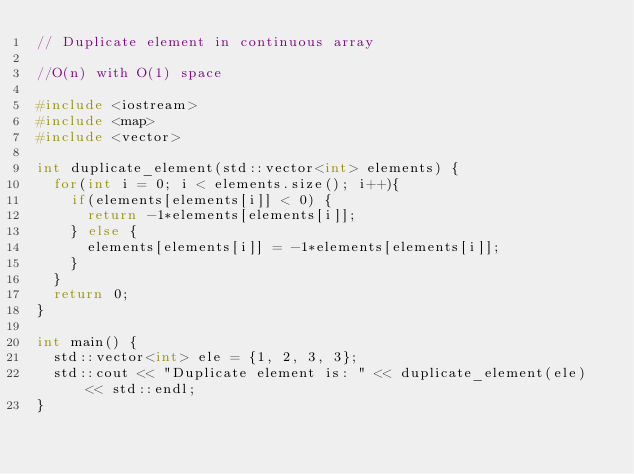<code> <loc_0><loc_0><loc_500><loc_500><_C++_>// Duplicate element in continuous array

//O(n) with O(1) space

#include <iostream>
#include <map>
#include <vector>

int duplicate_element(std::vector<int> elements) {
	for(int i = 0; i < elements.size(); i++){
		if(elements[elements[i]] < 0) {
			return -1*elements[elements[i]];
		} else {
			elements[elements[i]] = -1*elements[elements[i]];
		}
	}
	return 0;
}

int main() {
	std::vector<int> ele = {1, 2, 3, 3};
	std::cout << "Duplicate element is: " << duplicate_element(ele) << std::endl;
}</code> 